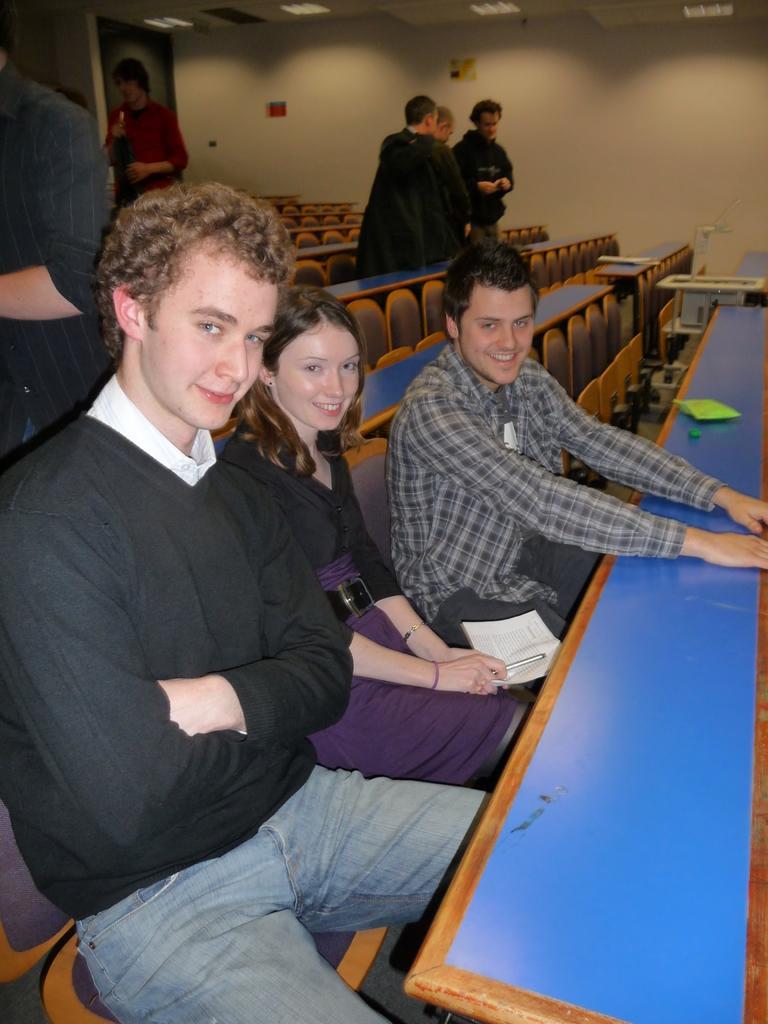How would you summarize this image in a sentence or two? There are three persons sitting on the chairs. This is table. And here we can see some persons are standing on the floor. In the background there is a wall and these are the lights. 